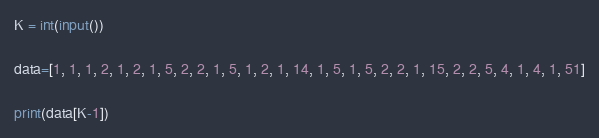<code> <loc_0><loc_0><loc_500><loc_500><_Python_>K = int(input())

data=[1, 1, 1, 2, 1, 2, 1, 5, 2, 2, 1, 5, 1, 2, 1, 14, 1, 5, 1, 5, 2, 2, 1, 15, 2, 2, 5, 4, 1, 4, 1, 51]

print(data[K-1])</code> 